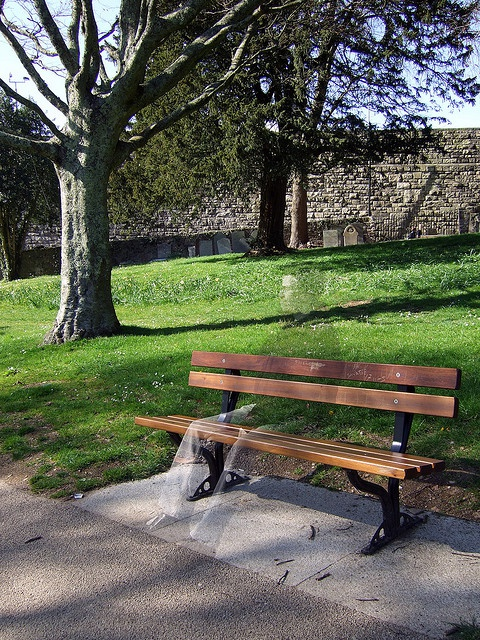Describe the objects in this image and their specific colors. I can see a bench in purple, black, brown, gray, and olive tones in this image. 